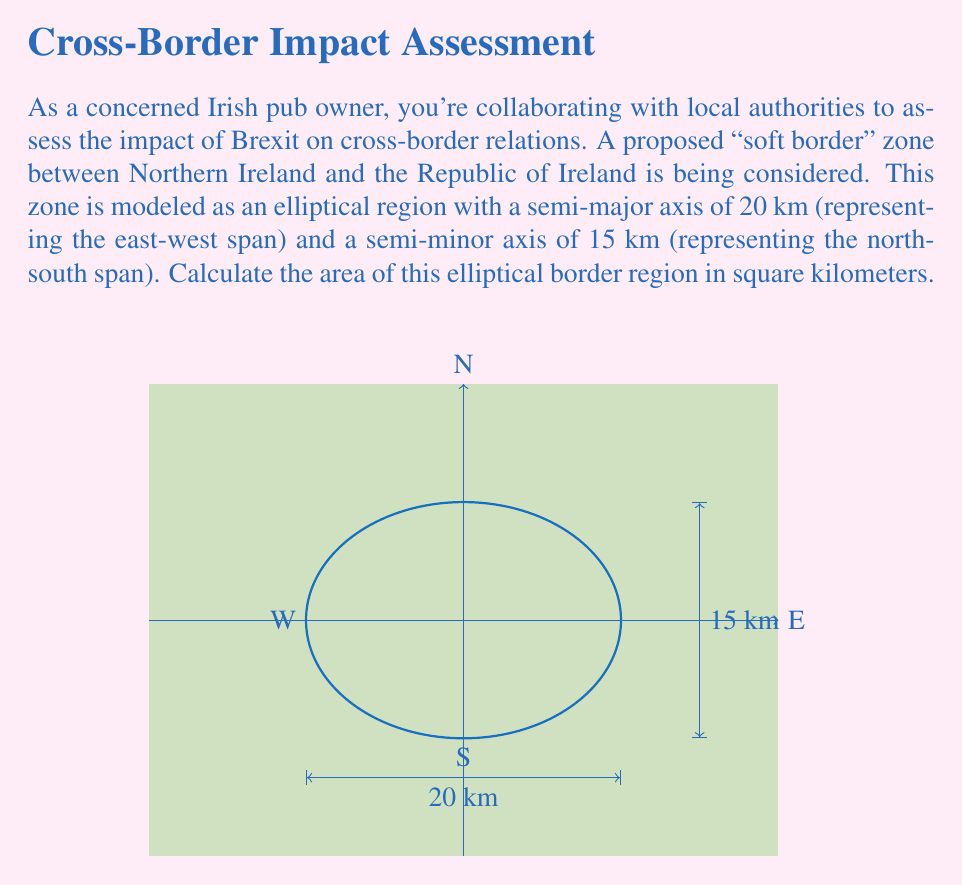Could you help me with this problem? To calculate the area of an elliptical region using conic sections, we'll follow these steps:

1) The general formula for the area of an ellipse is:

   $$A = \pi ab$$

   where $a$ is the length of the semi-major axis and $b$ is the length of the semi-minor axis.

2) In this case:
   $a = 20$ km (east-west span)
   $b = 15$ km (north-south span)

3) Substituting these values into the formula:

   $$A = \pi (20)(15)$$

4) Simplify:
   $$A = 300\pi$$

5) Calculate the final value (rounded to two decimal places):
   $$A \approx 942.48 \text{ km}^2$$

This elliptical area represents the "soft border" zone between Northern Ireland and the Republic of Ireland, which is crucial for understanding the potential impact of Brexit on cross-border relations and local communities.
Answer: $942.48 \text{ km}^2$ 